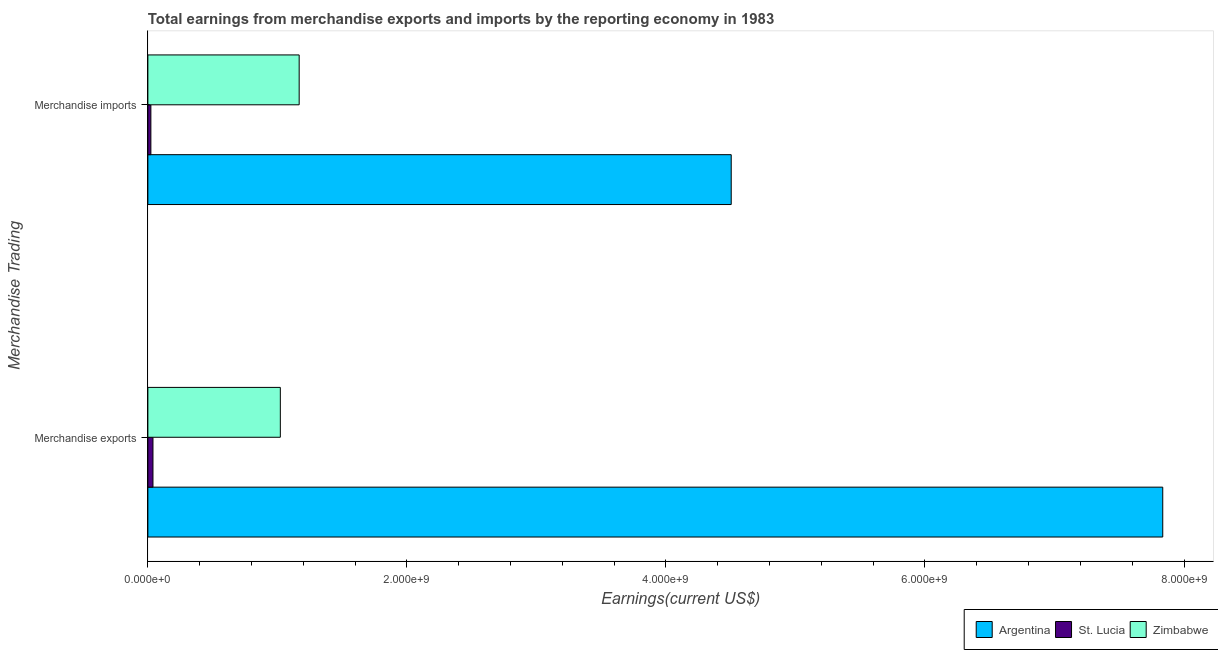Are the number of bars per tick equal to the number of legend labels?
Ensure brevity in your answer.  Yes. Are the number of bars on each tick of the Y-axis equal?
Your answer should be compact. Yes. How many bars are there on the 2nd tick from the bottom?
Provide a short and direct response. 3. What is the earnings from merchandise imports in Argentina?
Offer a terse response. 4.50e+09. Across all countries, what is the maximum earnings from merchandise exports?
Keep it short and to the point. 7.84e+09. Across all countries, what is the minimum earnings from merchandise imports?
Provide a short and direct response. 2.32e+07. In which country was the earnings from merchandise imports minimum?
Make the answer very short. St. Lucia. What is the total earnings from merchandise exports in the graph?
Make the answer very short. 8.90e+09. What is the difference between the earnings from merchandise exports in Argentina and that in Zimbabwe?
Offer a terse response. 6.81e+09. What is the difference between the earnings from merchandise imports in Zimbabwe and the earnings from merchandise exports in St. Lucia?
Make the answer very short. 1.13e+09. What is the average earnings from merchandise imports per country?
Keep it short and to the point. 1.90e+09. What is the difference between the earnings from merchandise imports and earnings from merchandise exports in Zimbabwe?
Offer a terse response. 1.45e+08. What is the ratio of the earnings from merchandise imports in Argentina to that in Zimbabwe?
Give a very brief answer. 3.86. Is the earnings from merchandise imports in St. Lucia less than that in Zimbabwe?
Your answer should be very brief. Yes. Are all the bars in the graph horizontal?
Provide a succinct answer. Yes. What is the difference between two consecutive major ticks on the X-axis?
Your answer should be compact. 2.00e+09. Are the values on the major ticks of X-axis written in scientific E-notation?
Your answer should be compact. Yes. Does the graph contain any zero values?
Ensure brevity in your answer.  No. Where does the legend appear in the graph?
Offer a terse response. Bottom right. What is the title of the graph?
Your answer should be compact. Total earnings from merchandise exports and imports by the reporting economy in 1983. What is the label or title of the X-axis?
Your response must be concise. Earnings(current US$). What is the label or title of the Y-axis?
Your answer should be very brief. Merchandise Trading. What is the Earnings(current US$) of Argentina in Merchandise exports?
Provide a short and direct response. 7.84e+09. What is the Earnings(current US$) of St. Lucia in Merchandise exports?
Provide a succinct answer. 3.94e+07. What is the Earnings(current US$) in Zimbabwe in Merchandise exports?
Give a very brief answer. 1.02e+09. What is the Earnings(current US$) of Argentina in Merchandise imports?
Make the answer very short. 4.50e+09. What is the Earnings(current US$) of St. Lucia in Merchandise imports?
Offer a terse response. 2.32e+07. What is the Earnings(current US$) in Zimbabwe in Merchandise imports?
Offer a terse response. 1.17e+09. Across all Merchandise Trading, what is the maximum Earnings(current US$) of Argentina?
Give a very brief answer. 7.84e+09. Across all Merchandise Trading, what is the maximum Earnings(current US$) in St. Lucia?
Offer a very short reply. 3.94e+07. Across all Merchandise Trading, what is the maximum Earnings(current US$) of Zimbabwe?
Ensure brevity in your answer.  1.17e+09. Across all Merchandise Trading, what is the minimum Earnings(current US$) in Argentina?
Offer a terse response. 4.50e+09. Across all Merchandise Trading, what is the minimum Earnings(current US$) in St. Lucia?
Offer a very short reply. 2.32e+07. Across all Merchandise Trading, what is the minimum Earnings(current US$) of Zimbabwe?
Give a very brief answer. 1.02e+09. What is the total Earnings(current US$) of Argentina in the graph?
Your response must be concise. 1.23e+1. What is the total Earnings(current US$) in St. Lucia in the graph?
Your answer should be compact. 6.25e+07. What is the total Earnings(current US$) in Zimbabwe in the graph?
Make the answer very short. 2.19e+09. What is the difference between the Earnings(current US$) of Argentina in Merchandise exports and that in Merchandise imports?
Offer a terse response. 3.33e+09. What is the difference between the Earnings(current US$) of St. Lucia in Merchandise exports and that in Merchandise imports?
Offer a terse response. 1.62e+07. What is the difference between the Earnings(current US$) of Zimbabwe in Merchandise exports and that in Merchandise imports?
Provide a short and direct response. -1.45e+08. What is the difference between the Earnings(current US$) in Argentina in Merchandise exports and the Earnings(current US$) in St. Lucia in Merchandise imports?
Provide a succinct answer. 7.81e+09. What is the difference between the Earnings(current US$) in Argentina in Merchandise exports and the Earnings(current US$) in Zimbabwe in Merchandise imports?
Ensure brevity in your answer.  6.67e+09. What is the difference between the Earnings(current US$) in St. Lucia in Merchandise exports and the Earnings(current US$) in Zimbabwe in Merchandise imports?
Ensure brevity in your answer.  -1.13e+09. What is the average Earnings(current US$) in Argentina per Merchandise Trading?
Ensure brevity in your answer.  6.17e+09. What is the average Earnings(current US$) in St. Lucia per Merchandise Trading?
Your response must be concise. 3.13e+07. What is the average Earnings(current US$) of Zimbabwe per Merchandise Trading?
Your answer should be compact. 1.10e+09. What is the difference between the Earnings(current US$) of Argentina and Earnings(current US$) of St. Lucia in Merchandise exports?
Provide a short and direct response. 7.80e+09. What is the difference between the Earnings(current US$) in Argentina and Earnings(current US$) in Zimbabwe in Merchandise exports?
Your response must be concise. 6.81e+09. What is the difference between the Earnings(current US$) of St. Lucia and Earnings(current US$) of Zimbabwe in Merchandise exports?
Your answer should be very brief. -9.83e+08. What is the difference between the Earnings(current US$) in Argentina and Earnings(current US$) in St. Lucia in Merchandise imports?
Give a very brief answer. 4.48e+09. What is the difference between the Earnings(current US$) in Argentina and Earnings(current US$) in Zimbabwe in Merchandise imports?
Ensure brevity in your answer.  3.34e+09. What is the difference between the Earnings(current US$) in St. Lucia and Earnings(current US$) in Zimbabwe in Merchandise imports?
Offer a terse response. -1.14e+09. What is the ratio of the Earnings(current US$) of Argentina in Merchandise exports to that in Merchandise imports?
Your answer should be very brief. 1.74. What is the ratio of the Earnings(current US$) of St. Lucia in Merchandise exports to that in Merchandise imports?
Offer a very short reply. 1.7. What is the ratio of the Earnings(current US$) in Zimbabwe in Merchandise exports to that in Merchandise imports?
Your response must be concise. 0.88. What is the difference between the highest and the second highest Earnings(current US$) of Argentina?
Offer a very short reply. 3.33e+09. What is the difference between the highest and the second highest Earnings(current US$) of St. Lucia?
Offer a very short reply. 1.62e+07. What is the difference between the highest and the second highest Earnings(current US$) in Zimbabwe?
Your response must be concise. 1.45e+08. What is the difference between the highest and the lowest Earnings(current US$) in Argentina?
Give a very brief answer. 3.33e+09. What is the difference between the highest and the lowest Earnings(current US$) of St. Lucia?
Your response must be concise. 1.62e+07. What is the difference between the highest and the lowest Earnings(current US$) in Zimbabwe?
Give a very brief answer. 1.45e+08. 